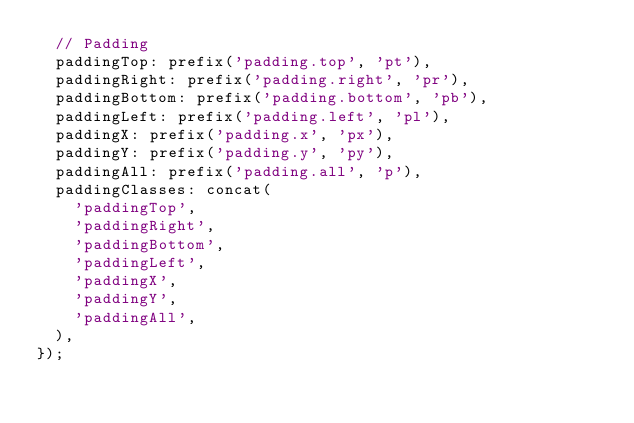Convert code to text. <code><loc_0><loc_0><loc_500><loc_500><_JavaScript_>  // Padding
  paddingTop: prefix('padding.top', 'pt'),
  paddingRight: prefix('padding.right', 'pr'),
  paddingBottom: prefix('padding.bottom', 'pb'),
  paddingLeft: prefix('padding.left', 'pl'),
  paddingX: prefix('padding.x', 'px'),
  paddingY: prefix('padding.y', 'py'),
  paddingAll: prefix('padding.all', 'p'),
  paddingClasses: concat(
    'paddingTop',
    'paddingRight',
    'paddingBottom',
    'paddingLeft',
    'paddingX',
    'paddingY',
    'paddingAll',
  ),
});
</code> 